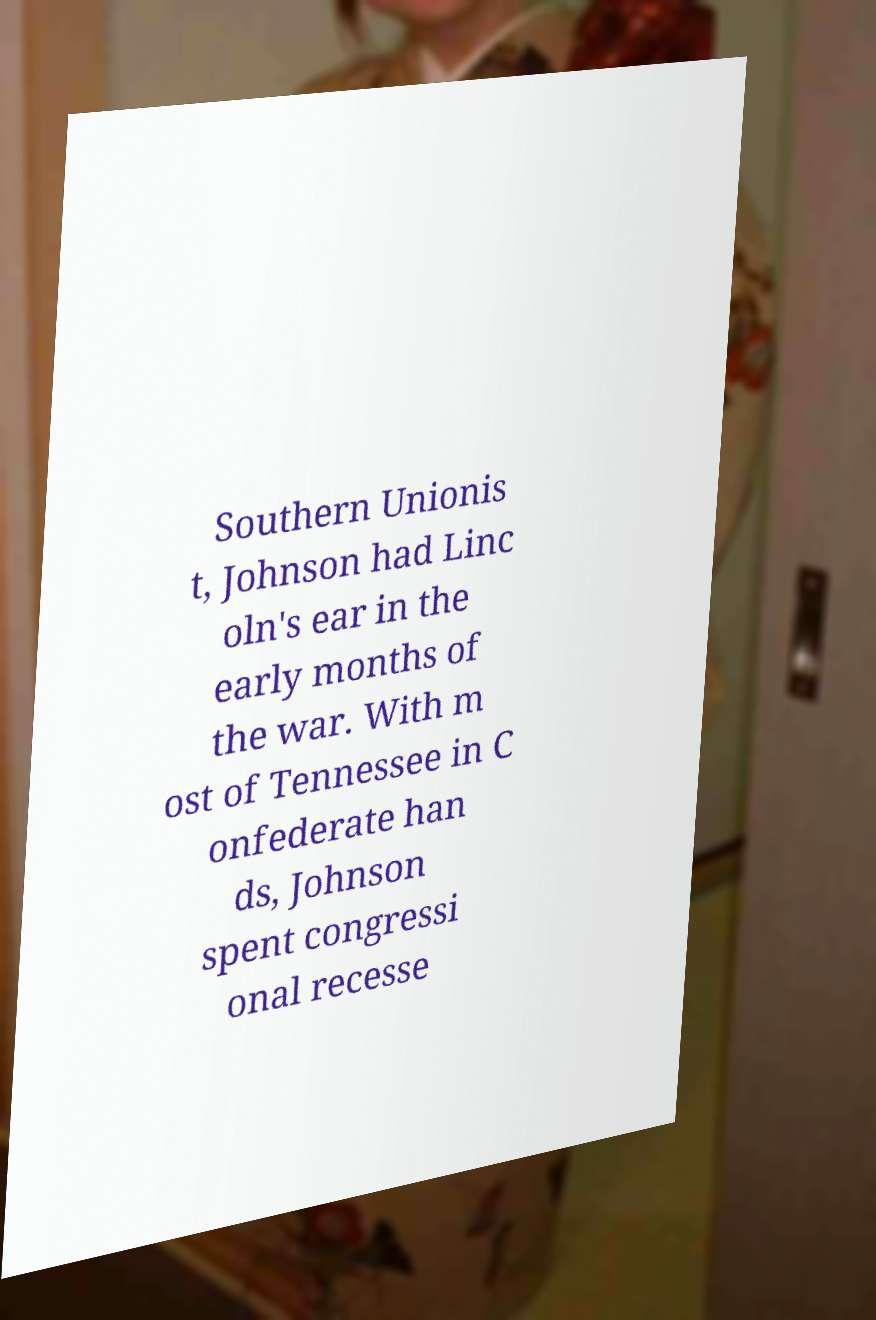What messages or text are displayed in this image? I need them in a readable, typed format. Southern Unionis t, Johnson had Linc oln's ear in the early months of the war. With m ost of Tennessee in C onfederate han ds, Johnson spent congressi onal recesse 